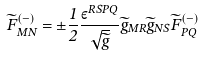Convert formula to latex. <formula><loc_0><loc_0><loc_500><loc_500>\widetilde { F } ^ { ( - ) } _ { M N } = \pm \frac { 1 } { 2 } \frac { \varepsilon ^ { R S P Q } } { \sqrt { \widetilde { g } } } \widetilde { g } _ { M R } \widetilde { g } _ { N S } \widetilde { F } ^ { ( - ) } _ { P Q }</formula> 